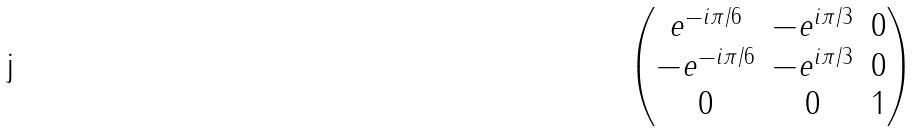Convert formula to latex. <formula><loc_0><loc_0><loc_500><loc_500>\begin{pmatrix} e ^ { - i \pi / 6 } & - e ^ { i \pi / 3 } & 0 \\ - e ^ { - i \pi / 6 } & - e ^ { i \pi / 3 } & 0 \\ 0 & 0 & 1 \end{pmatrix}</formula> 